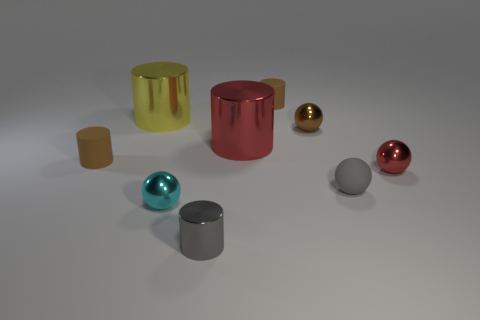Subtract all yellow cylinders. How many cylinders are left? 4 Subtract all gray cylinders. How many cylinders are left? 4 Subtract 1 cylinders. How many cylinders are left? 4 Subtract all cyan cylinders. Subtract all yellow cubes. How many cylinders are left? 5 Add 1 big yellow metal things. How many objects exist? 10 Subtract all cylinders. How many objects are left? 4 Subtract all small rubber things. Subtract all red shiny cylinders. How many objects are left? 5 Add 4 tiny cyan shiny things. How many tiny cyan shiny things are left? 5 Add 5 red metallic cylinders. How many red metallic cylinders exist? 6 Subtract 1 yellow cylinders. How many objects are left? 8 